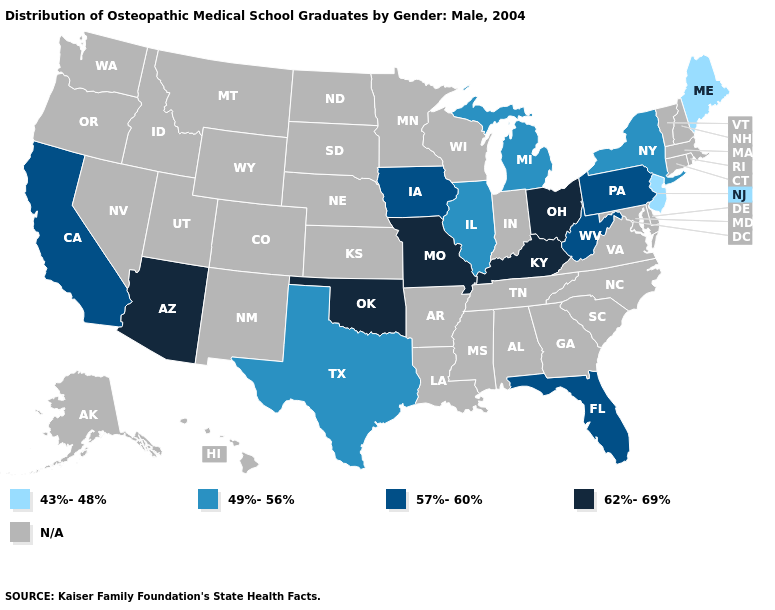What is the highest value in states that border Delaware?
Answer briefly. 57%-60%. Name the states that have a value in the range 49%-56%?
Write a very short answer. Illinois, Michigan, New York, Texas. Among the states that border Indiana , which have the lowest value?
Give a very brief answer. Illinois, Michigan. Does Texas have the lowest value in the South?
Give a very brief answer. Yes. What is the value of Louisiana?
Quick response, please. N/A. Name the states that have a value in the range 49%-56%?
Short answer required. Illinois, Michigan, New York, Texas. Name the states that have a value in the range 57%-60%?
Concise answer only. California, Florida, Iowa, Pennsylvania, West Virginia. Which states have the lowest value in the West?
Write a very short answer. California. What is the value of Alaska?
Concise answer only. N/A. Name the states that have a value in the range 43%-48%?
Write a very short answer. Maine, New Jersey. What is the lowest value in states that border Pennsylvania?
Write a very short answer. 43%-48%. Name the states that have a value in the range 43%-48%?
Answer briefly. Maine, New Jersey. 